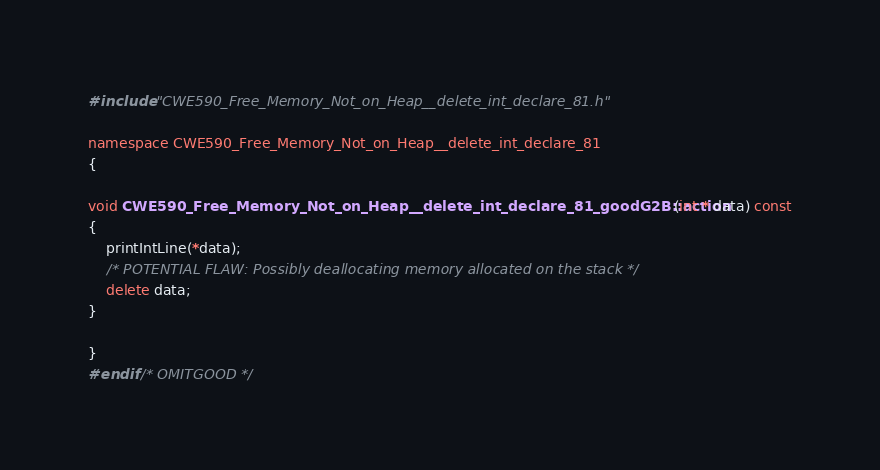<code> <loc_0><loc_0><loc_500><loc_500><_C++_>#include "CWE590_Free_Memory_Not_on_Heap__delete_int_declare_81.h"

namespace CWE590_Free_Memory_Not_on_Heap__delete_int_declare_81
{

void CWE590_Free_Memory_Not_on_Heap__delete_int_declare_81_goodG2B::action(int * data) const
{
    printIntLine(*data);
    /* POTENTIAL FLAW: Possibly deallocating memory allocated on the stack */
    delete data;
}

}
#endif /* OMITGOOD */
</code> 